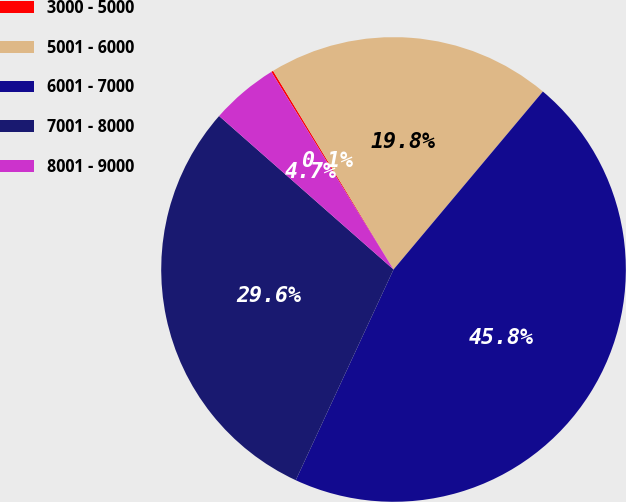Convert chart. <chart><loc_0><loc_0><loc_500><loc_500><pie_chart><fcel>3000 - 5000<fcel>5001 - 6000<fcel>6001 - 7000<fcel>7001 - 8000<fcel>8001 - 9000<nl><fcel>0.14%<fcel>19.79%<fcel>45.8%<fcel>29.57%<fcel>4.7%<nl></chart> 